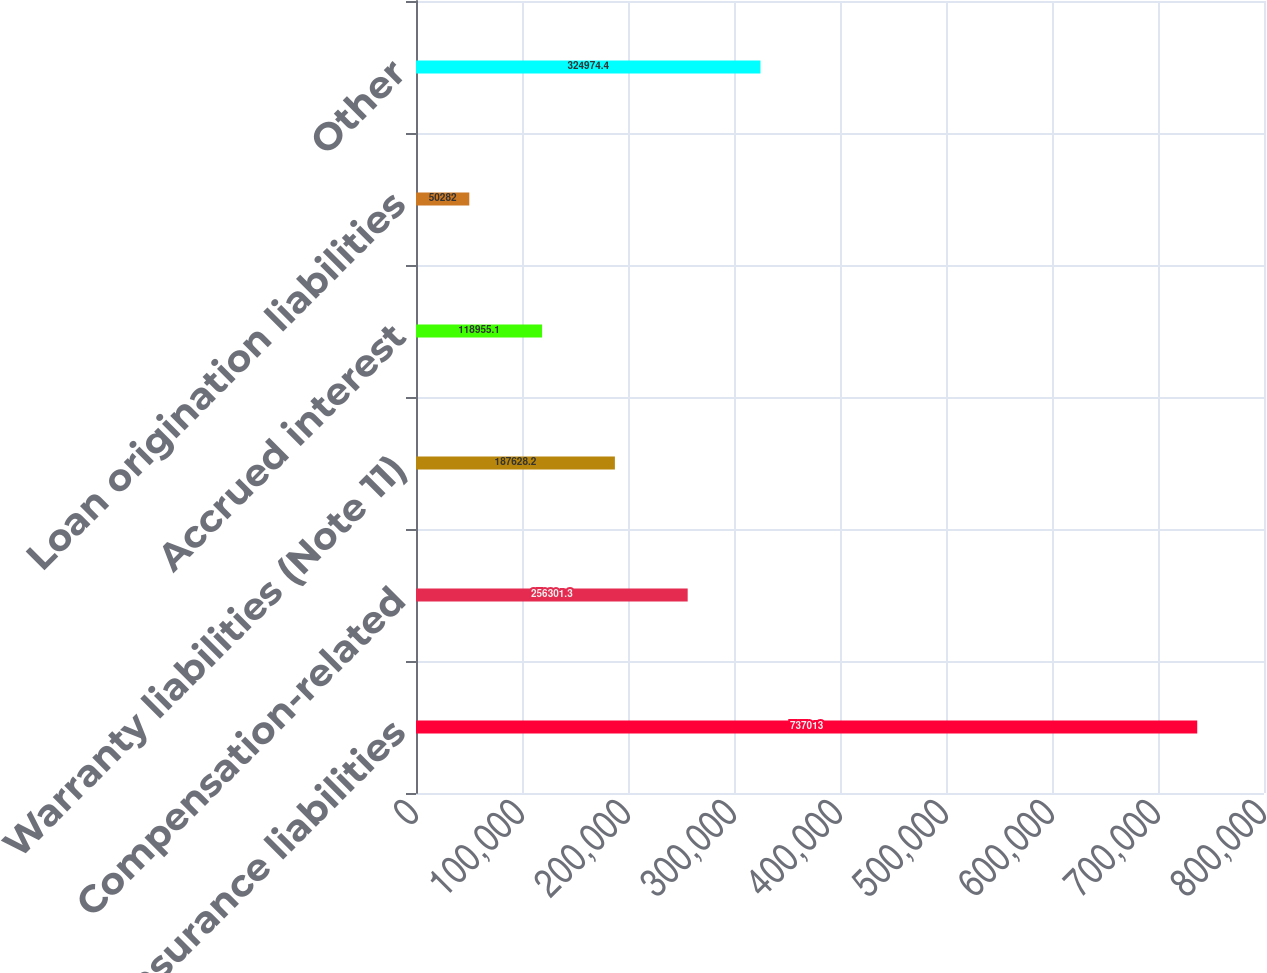<chart> <loc_0><loc_0><loc_500><loc_500><bar_chart><fcel>Self-insurance liabilities<fcel>Compensation-related<fcel>Warranty liabilities (Note 11)<fcel>Accrued interest<fcel>Loan origination liabilities<fcel>Other<nl><fcel>737013<fcel>256301<fcel>187628<fcel>118955<fcel>50282<fcel>324974<nl></chart> 